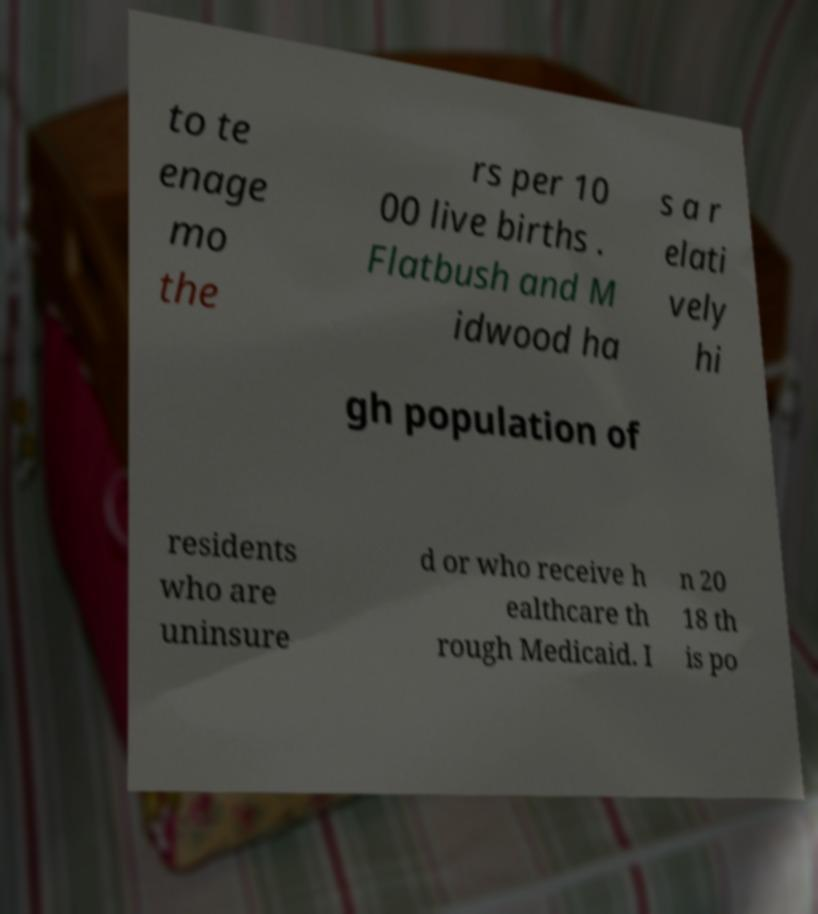Please read and relay the text visible in this image. What does it say? to te enage mo the rs per 10 00 live births . Flatbush and M idwood ha s a r elati vely hi gh population of residents who are uninsure d or who receive h ealthcare th rough Medicaid. I n 20 18 th is po 